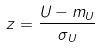Convert formula to latex. <formula><loc_0><loc_0><loc_500><loc_500>z = \frac { U - m _ { U } } { \sigma _ { U } }</formula> 